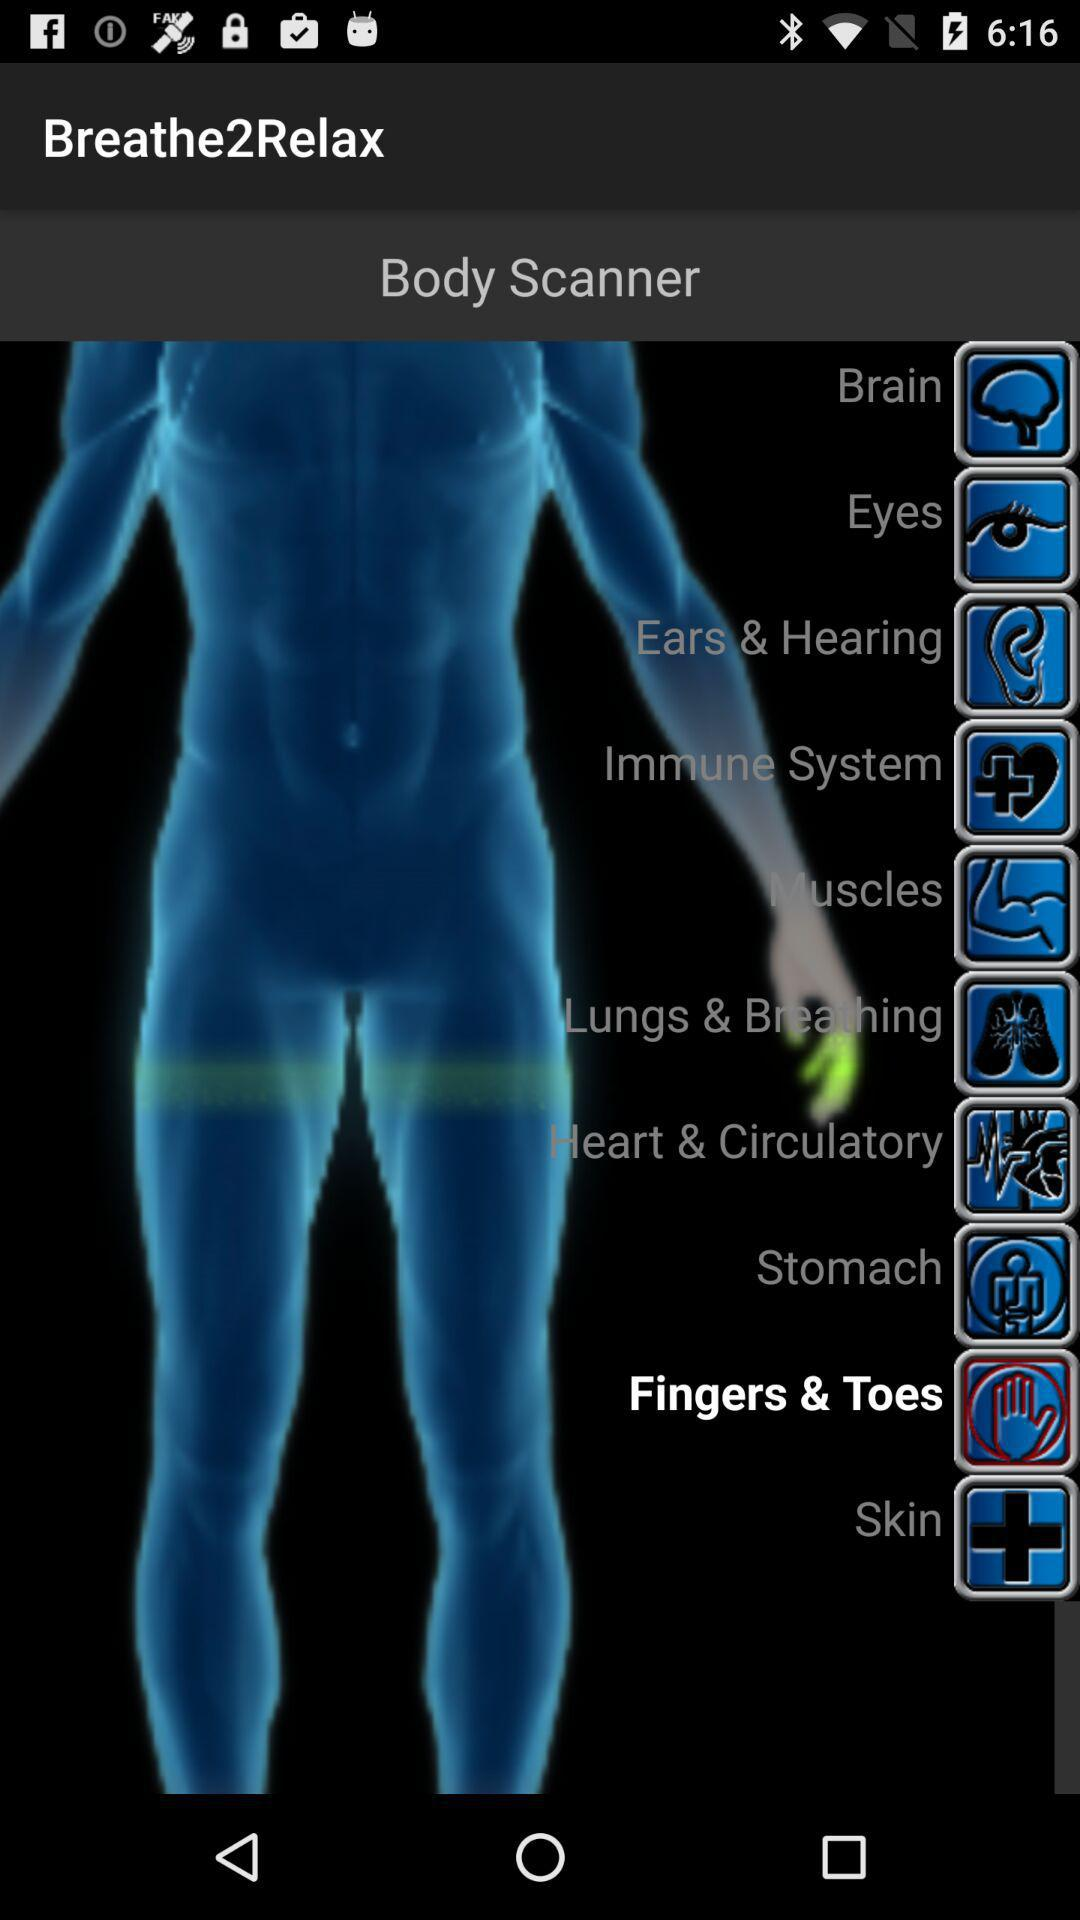What is the application name? The application name is "Breathe2Relax". 